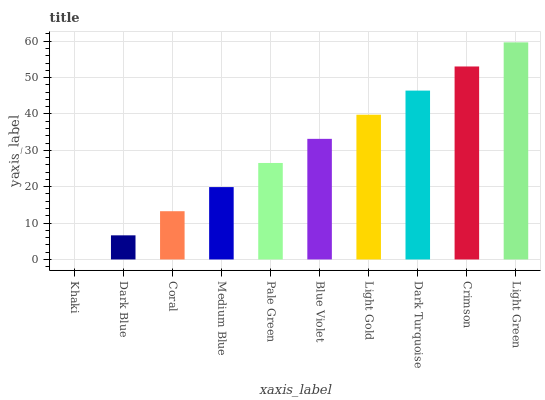Is Khaki the minimum?
Answer yes or no. Yes. Is Light Green the maximum?
Answer yes or no. Yes. Is Dark Blue the minimum?
Answer yes or no. No. Is Dark Blue the maximum?
Answer yes or no. No. Is Dark Blue greater than Khaki?
Answer yes or no. Yes. Is Khaki less than Dark Blue?
Answer yes or no. Yes. Is Khaki greater than Dark Blue?
Answer yes or no. No. Is Dark Blue less than Khaki?
Answer yes or no. No. Is Blue Violet the high median?
Answer yes or no. Yes. Is Pale Green the low median?
Answer yes or no. Yes. Is Light Green the high median?
Answer yes or no. No. Is Light Green the low median?
Answer yes or no. No. 